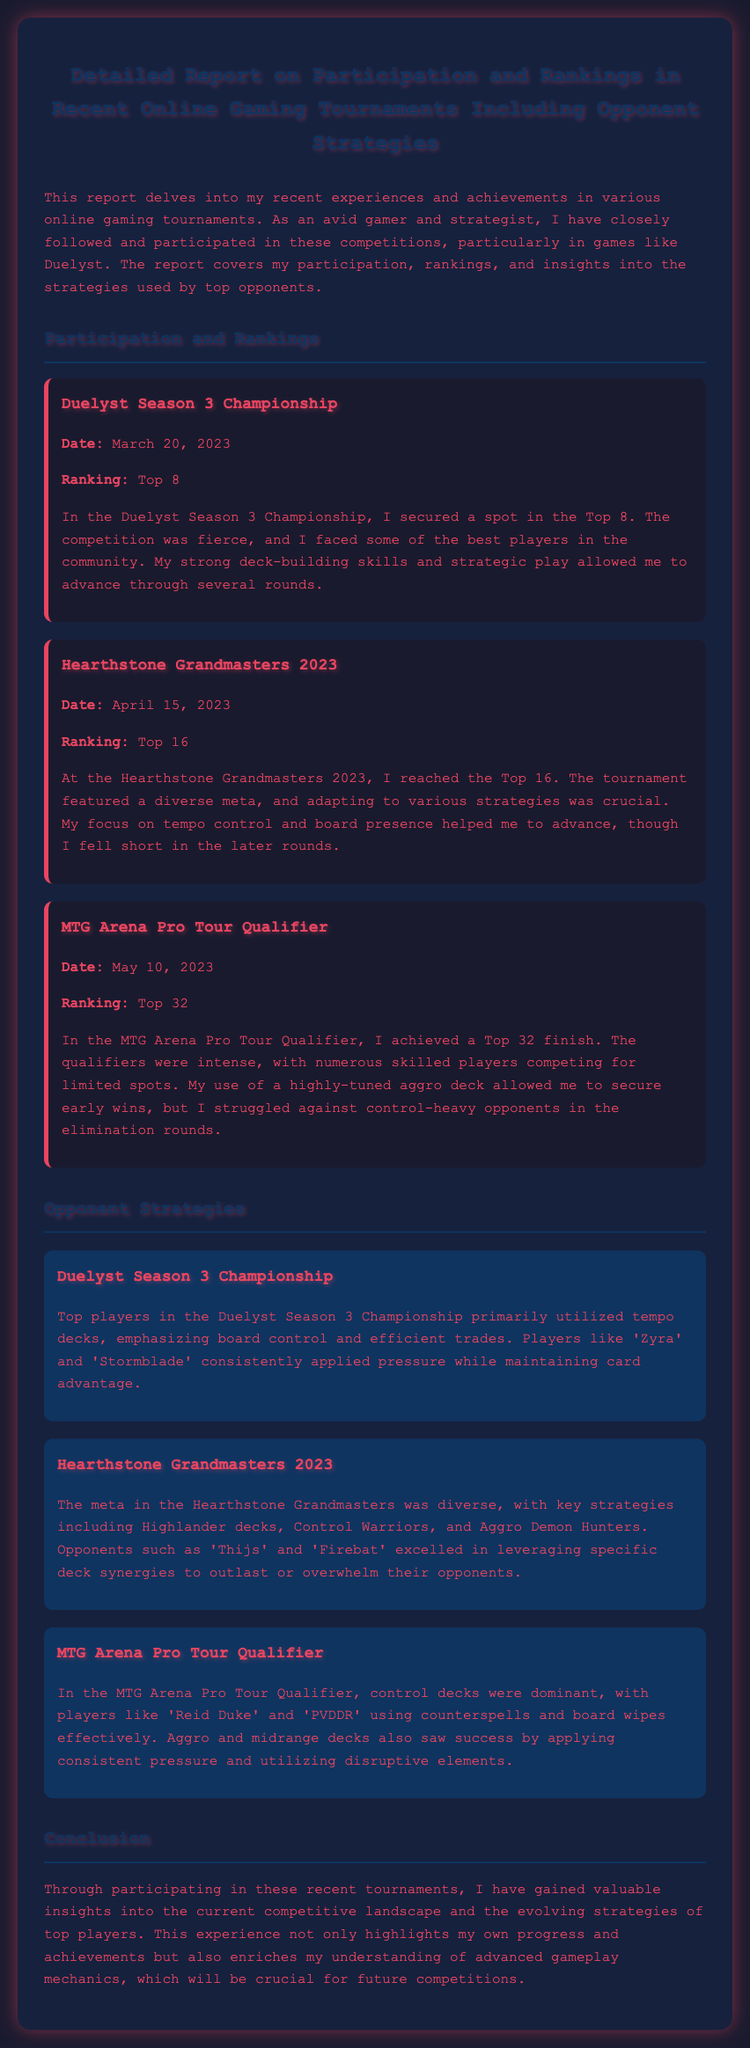What is the ranking achieved in the Duelyst Season 3 Championship? The report states that in the Duelyst Season 3 Championship, the ranking achieved was Top 8.
Answer: Top 8 What date was the Hearthstone Grandmasters 2023 held? The tournament took place on April 15, 2023.
Answer: April 15, 2023 Which deck strategy was primarily used in the Duelyst Season 3 Championship? The top players in the Duelyst Season 3 Championship primarily utilized tempo decks.
Answer: Tempo decks What was the final ranking in the MTG Arena Pro Tour Qualifier? The report mentions achieving a Top 32 finish in the MTG Arena Pro Tour Qualifier.
Answer: Top 32 Who were two prominent opponents mentioned in the Hearthstone Grandmasters 2023? The notable opponents mentioned in the tournament include 'Thijs' and 'Firebat'.
Answer: 'Thijs' and 'Firebat' What was the author's focus during the Hearthstone Grandmasters 2023? The report indicates that the author's focus during the tournament was on tempo control and board presence.
Answer: Tempo control and board presence What type of decks were dominant in the MTG Arena Pro Tour Qualifier? The dominant decks in the MTG Arena Pro Tour Qualifier were control decks.
Answer: Control decks In which tournament did the author face control-heavy opponents? The author struggled against control-heavy opponents in the MTG Arena Pro Tour Qualifier.
Answer: MTG Arena Pro Tour Qualifier What insight does the author gain from the recent tournaments? The insight gained is into the current competitive landscape and evolving strategies of top players.
Answer: Current competitive landscape and evolving strategies 